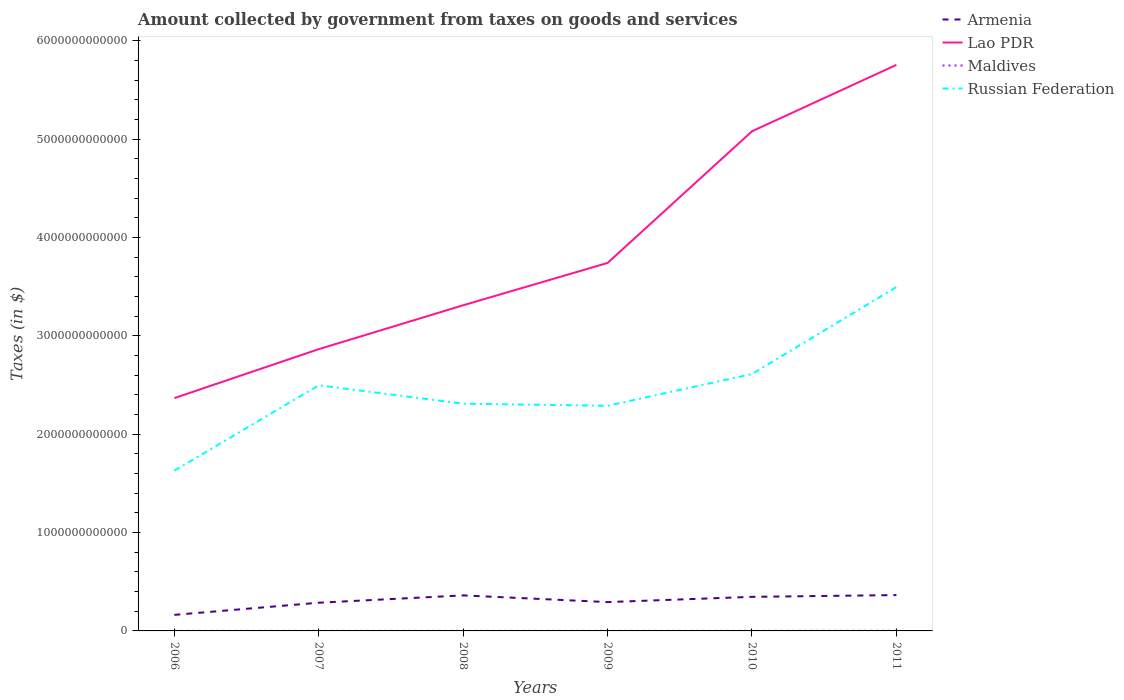How many different coloured lines are there?
Provide a succinct answer. 4. Does the line corresponding to Armenia intersect with the line corresponding to Russian Federation?
Keep it short and to the point. No. Is the number of lines equal to the number of legend labels?
Offer a terse response. Yes. Across all years, what is the maximum amount collected by government from taxes on goods and services in Russian Federation?
Your response must be concise. 1.63e+12. In which year was the amount collected by government from taxes on goods and services in Armenia maximum?
Provide a short and direct response. 2006. What is the total amount collected by government from taxes on goods and services in Lao PDR in the graph?
Offer a very short reply. -3.39e+12. What is the difference between the highest and the second highest amount collected by government from taxes on goods and services in Russian Federation?
Your answer should be very brief. 1.87e+12. What is the difference between the highest and the lowest amount collected by government from taxes on goods and services in Lao PDR?
Ensure brevity in your answer.  2. Is the amount collected by government from taxes on goods and services in Lao PDR strictly greater than the amount collected by government from taxes on goods and services in Armenia over the years?
Give a very brief answer. No. What is the difference between two consecutive major ticks on the Y-axis?
Your response must be concise. 1.00e+12. Are the values on the major ticks of Y-axis written in scientific E-notation?
Your answer should be very brief. No. Does the graph contain grids?
Offer a terse response. No. How many legend labels are there?
Make the answer very short. 4. What is the title of the graph?
Your answer should be very brief. Amount collected by government from taxes on goods and services. What is the label or title of the Y-axis?
Your answer should be compact. Taxes (in $). What is the Taxes (in $) in Armenia in 2006?
Provide a succinct answer. 1.63e+11. What is the Taxes (in $) in Lao PDR in 2006?
Offer a terse response. 2.37e+12. What is the Taxes (in $) in Maldives in 2006?
Your response must be concise. 5.49e+08. What is the Taxes (in $) in Russian Federation in 2006?
Offer a very short reply. 1.63e+12. What is the Taxes (in $) in Armenia in 2007?
Your response must be concise. 2.87e+11. What is the Taxes (in $) in Lao PDR in 2007?
Ensure brevity in your answer.  2.86e+12. What is the Taxes (in $) in Maldives in 2007?
Give a very brief answer. 6.08e+08. What is the Taxes (in $) of Russian Federation in 2007?
Your response must be concise. 2.50e+12. What is the Taxes (in $) of Armenia in 2008?
Provide a succinct answer. 3.61e+11. What is the Taxes (in $) of Lao PDR in 2008?
Give a very brief answer. 3.31e+12. What is the Taxes (in $) of Maldives in 2008?
Give a very brief answer. 6.38e+08. What is the Taxes (in $) of Russian Federation in 2008?
Keep it short and to the point. 2.31e+12. What is the Taxes (in $) of Armenia in 2009?
Provide a succinct answer. 2.93e+11. What is the Taxes (in $) of Lao PDR in 2009?
Provide a short and direct response. 3.74e+12. What is the Taxes (in $) in Maldives in 2009?
Ensure brevity in your answer.  6.10e+08. What is the Taxes (in $) in Russian Federation in 2009?
Your answer should be very brief. 2.29e+12. What is the Taxes (in $) of Armenia in 2010?
Offer a terse response. 3.46e+11. What is the Taxes (in $) in Lao PDR in 2010?
Keep it short and to the point. 5.08e+12. What is the Taxes (in $) in Maldives in 2010?
Keep it short and to the point. 6.35e+08. What is the Taxes (in $) of Russian Federation in 2010?
Your answer should be compact. 2.61e+12. What is the Taxes (in $) in Armenia in 2011?
Offer a very short reply. 3.64e+11. What is the Taxes (in $) in Lao PDR in 2011?
Keep it short and to the point. 5.75e+12. What is the Taxes (in $) of Maldives in 2011?
Provide a succinct answer. 1.66e+09. What is the Taxes (in $) in Russian Federation in 2011?
Your answer should be very brief. 3.50e+12. Across all years, what is the maximum Taxes (in $) of Armenia?
Ensure brevity in your answer.  3.64e+11. Across all years, what is the maximum Taxes (in $) in Lao PDR?
Keep it short and to the point. 5.75e+12. Across all years, what is the maximum Taxes (in $) in Maldives?
Offer a terse response. 1.66e+09. Across all years, what is the maximum Taxes (in $) in Russian Federation?
Your answer should be very brief. 3.50e+12. Across all years, what is the minimum Taxes (in $) of Armenia?
Ensure brevity in your answer.  1.63e+11. Across all years, what is the minimum Taxes (in $) of Lao PDR?
Provide a short and direct response. 2.37e+12. Across all years, what is the minimum Taxes (in $) in Maldives?
Ensure brevity in your answer.  5.49e+08. Across all years, what is the minimum Taxes (in $) of Russian Federation?
Your answer should be very brief. 1.63e+12. What is the total Taxes (in $) of Armenia in the graph?
Keep it short and to the point. 1.82e+12. What is the total Taxes (in $) of Lao PDR in the graph?
Give a very brief answer. 2.31e+13. What is the total Taxes (in $) of Maldives in the graph?
Your answer should be compact. 4.70e+09. What is the total Taxes (in $) of Russian Federation in the graph?
Ensure brevity in your answer.  1.48e+13. What is the difference between the Taxes (in $) of Armenia in 2006 and that in 2007?
Provide a succinct answer. -1.23e+11. What is the difference between the Taxes (in $) in Lao PDR in 2006 and that in 2007?
Make the answer very short. -4.98e+11. What is the difference between the Taxes (in $) of Maldives in 2006 and that in 2007?
Your answer should be very brief. -5.84e+07. What is the difference between the Taxes (in $) of Russian Federation in 2006 and that in 2007?
Your answer should be compact. -8.68e+11. What is the difference between the Taxes (in $) in Armenia in 2006 and that in 2008?
Make the answer very short. -1.98e+11. What is the difference between the Taxes (in $) in Lao PDR in 2006 and that in 2008?
Offer a terse response. -9.44e+11. What is the difference between the Taxes (in $) of Maldives in 2006 and that in 2008?
Offer a very short reply. -8.81e+07. What is the difference between the Taxes (in $) of Russian Federation in 2006 and that in 2008?
Your answer should be compact. -6.81e+11. What is the difference between the Taxes (in $) of Armenia in 2006 and that in 2009?
Keep it short and to the point. -1.30e+11. What is the difference between the Taxes (in $) of Lao PDR in 2006 and that in 2009?
Keep it short and to the point. -1.37e+12. What is the difference between the Taxes (in $) in Maldives in 2006 and that in 2009?
Your answer should be very brief. -6.10e+07. What is the difference between the Taxes (in $) in Russian Federation in 2006 and that in 2009?
Your answer should be compact. -6.60e+11. What is the difference between the Taxes (in $) of Armenia in 2006 and that in 2010?
Keep it short and to the point. -1.83e+11. What is the difference between the Taxes (in $) in Lao PDR in 2006 and that in 2010?
Your answer should be very brief. -2.71e+12. What is the difference between the Taxes (in $) in Maldives in 2006 and that in 2010?
Offer a very short reply. -8.57e+07. What is the difference between the Taxes (in $) of Russian Federation in 2006 and that in 2010?
Ensure brevity in your answer.  -9.83e+11. What is the difference between the Taxes (in $) in Armenia in 2006 and that in 2011?
Your response must be concise. -2.01e+11. What is the difference between the Taxes (in $) in Lao PDR in 2006 and that in 2011?
Provide a succinct answer. -3.39e+12. What is the difference between the Taxes (in $) of Maldives in 2006 and that in 2011?
Offer a terse response. -1.11e+09. What is the difference between the Taxes (in $) of Russian Federation in 2006 and that in 2011?
Give a very brief answer. -1.87e+12. What is the difference between the Taxes (in $) of Armenia in 2007 and that in 2008?
Keep it short and to the point. -7.45e+1. What is the difference between the Taxes (in $) of Lao PDR in 2007 and that in 2008?
Ensure brevity in your answer.  -4.46e+11. What is the difference between the Taxes (in $) in Maldives in 2007 and that in 2008?
Give a very brief answer. -2.97e+07. What is the difference between the Taxes (in $) in Russian Federation in 2007 and that in 2008?
Ensure brevity in your answer.  1.87e+11. What is the difference between the Taxes (in $) in Armenia in 2007 and that in 2009?
Your answer should be very brief. -6.40e+09. What is the difference between the Taxes (in $) of Lao PDR in 2007 and that in 2009?
Provide a short and direct response. -8.77e+11. What is the difference between the Taxes (in $) of Maldives in 2007 and that in 2009?
Give a very brief answer. -2.60e+06. What is the difference between the Taxes (in $) in Russian Federation in 2007 and that in 2009?
Keep it short and to the point. 2.08e+11. What is the difference between the Taxes (in $) in Armenia in 2007 and that in 2010?
Your response must be concise. -5.97e+1. What is the difference between the Taxes (in $) in Lao PDR in 2007 and that in 2010?
Your answer should be compact. -2.22e+12. What is the difference between the Taxes (in $) of Maldives in 2007 and that in 2010?
Your answer should be very brief. -2.73e+07. What is the difference between the Taxes (in $) of Russian Federation in 2007 and that in 2010?
Provide a short and direct response. -1.15e+11. What is the difference between the Taxes (in $) in Armenia in 2007 and that in 2011?
Offer a terse response. -7.77e+1. What is the difference between the Taxes (in $) in Lao PDR in 2007 and that in 2011?
Provide a short and direct response. -2.89e+12. What is the difference between the Taxes (in $) of Maldives in 2007 and that in 2011?
Keep it short and to the point. -1.05e+09. What is the difference between the Taxes (in $) of Russian Federation in 2007 and that in 2011?
Ensure brevity in your answer.  -9.99e+11. What is the difference between the Taxes (in $) in Armenia in 2008 and that in 2009?
Give a very brief answer. 6.81e+1. What is the difference between the Taxes (in $) of Lao PDR in 2008 and that in 2009?
Your answer should be very brief. -4.30e+11. What is the difference between the Taxes (in $) of Maldives in 2008 and that in 2009?
Offer a very short reply. 2.71e+07. What is the difference between the Taxes (in $) of Russian Federation in 2008 and that in 2009?
Make the answer very short. 2.16e+1. What is the difference between the Taxes (in $) in Armenia in 2008 and that in 2010?
Keep it short and to the point. 1.48e+1. What is the difference between the Taxes (in $) of Lao PDR in 2008 and that in 2010?
Make the answer very short. -1.77e+12. What is the difference between the Taxes (in $) in Maldives in 2008 and that in 2010?
Keep it short and to the point. 2.40e+06. What is the difference between the Taxes (in $) in Russian Federation in 2008 and that in 2010?
Keep it short and to the point. -3.01e+11. What is the difference between the Taxes (in $) in Armenia in 2008 and that in 2011?
Your response must be concise. -3.29e+09. What is the difference between the Taxes (in $) in Lao PDR in 2008 and that in 2011?
Make the answer very short. -2.44e+12. What is the difference between the Taxes (in $) of Maldives in 2008 and that in 2011?
Keep it short and to the point. -1.02e+09. What is the difference between the Taxes (in $) in Russian Federation in 2008 and that in 2011?
Give a very brief answer. -1.19e+12. What is the difference between the Taxes (in $) in Armenia in 2009 and that in 2010?
Keep it short and to the point. -5.33e+1. What is the difference between the Taxes (in $) in Lao PDR in 2009 and that in 2010?
Offer a very short reply. -1.34e+12. What is the difference between the Taxes (in $) in Maldives in 2009 and that in 2010?
Your response must be concise. -2.47e+07. What is the difference between the Taxes (in $) of Russian Federation in 2009 and that in 2010?
Offer a very short reply. -3.23e+11. What is the difference between the Taxes (in $) in Armenia in 2009 and that in 2011?
Make the answer very short. -7.13e+1. What is the difference between the Taxes (in $) in Lao PDR in 2009 and that in 2011?
Keep it short and to the point. -2.01e+12. What is the difference between the Taxes (in $) in Maldives in 2009 and that in 2011?
Your answer should be very brief. -1.05e+09. What is the difference between the Taxes (in $) in Russian Federation in 2009 and that in 2011?
Offer a terse response. -1.21e+12. What is the difference between the Taxes (in $) of Armenia in 2010 and that in 2011?
Your answer should be compact. -1.80e+1. What is the difference between the Taxes (in $) in Lao PDR in 2010 and that in 2011?
Give a very brief answer. -6.75e+11. What is the difference between the Taxes (in $) in Maldives in 2010 and that in 2011?
Give a very brief answer. -1.02e+09. What is the difference between the Taxes (in $) in Russian Federation in 2010 and that in 2011?
Ensure brevity in your answer.  -8.84e+11. What is the difference between the Taxes (in $) in Armenia in 2006 and the Taxes (in $) in Lao PDR in 2007?
Provide a succinct answer. -2.70e+12. What is the difference between the Taxes (in $) of Armenia in 2006 and the Taxes (in $) of Maldives in 2007?
Keep it short and to the point. 1.63e+11. What is the difference between the Taxes (in $) of Armenia in 2006 and the Taxes (in $) of Russian Federation in 2007?
Give a very brief answer. -2.33e+12. What is the difference between the Taxes (in $) of Lao PDR in 2006 and the Taxes (in $) of Maldives in 2007?
Keep it short and to the point. 2.37e+12. What is the difference between the Taxes (in $) in Lao PDR in 2006 and the Taxes (in $) in Russian Federation in 2007?
Your response must be concise. -1.30e+11. What is the difference between the Taxes (in $) in Maldives in 2006 and the Taxes (in $) in Russian Federation in 2007?
Ensure brevity in your answer.  -2.50e+12. What is the difference between the Taxes (in $) in Armenia in 2006 and the Taxes (in $) in Lao PDR in 2008?
Make the answer very short. -3.15e+12. What is the difference between the Taxes (in $) of Armenia in 2006 and the Taxes (in $) of Maldives in 2008?
Provide a short and direct response. 1.63e+11. What is the difference between the Taxes (in $) in Armenia in 2006 and the Taxes (in $) in Russian Federation in 2008?
Your response must be concise. -2.15e+12. What is the difference between the Taxes (in $) in Lao PDR in 2006 and the Taxes (in $) in Maldives in 2008?
Make the answer very short. 2.37e+12. What is the difference between the Taxes (in $) in Lao PDR in 2006 and the Taxes (in $) in Russian Federation in 2008?
Offer a very short reply. 5.63e+1. What is the difference between the Taxes (in $) in Maldives in 2006 and the Taxes (in $) in Russian Federation in 2008?
Provide a short and direct response. -2.31e+12. What is the difference between the Taxes (in $) of Armenia in 2006 and the Taxes (in $) of Lao PDR in 2009?
Offer a very short reply. -3.58e+12. What is the difference between the Taxes (in $) in Armenia in 2006 and the Taxes (in $) in Maldives in 2009?
Ensure brevity in your answer.  1.63e+11. What is the difference between the Taxes (in $) of Armenia in 2006 and the Taxes (in $) of Russian Federation in 2009?
Make the answer very short. -2.13e+12. What is the difference between the Taxes (in $) in Lao PDR in 2006 and the Taxes (in $) in Maldives in 2009?
Give a very brief answer. 2.37e+12. What is the difference between the Taxes (in $) of Lao PDR in 2006 and the Taxes (in $) of Russian Federation in 2009?
Your answer should be very brief. 7.79e+1. What is the difference between the Taxes (in $) of Maldives in 2006 and the Taxes (in $) of Russian Federation in 2009?
Provide a succinct answer. -2.29e+12. What is the difference between the Taxes (in $) in Armenia in 2006 and the Taxes (in $) in Lao PDR in 2010?
Your response must be concise. -4.92e+12. What is the difference between the Taxes (in $) in Armenia in 2006 and the Taxes (in $) in Maldives in 2010?
Give a very brief answer. 1.63e+11. What is the difference between the Taxes (in $) in Armenia in 2006 and the Taxes (in $) in Russian Federation in 2010?
Your response must be concise. -2.45e+12. What is the difference between the Taxes (in $) of Lao PDR in 2006 and the Taxes (in $) of Maldives in 2010?
Offer a very short reply. 2.37e+12. What is the difference between the Taxes (in $) in Lao PDR in 2006 and the Taxes (in $) in Russian Federation in 2010?
Your response must be concise. -2.45e+11. What is the difference between the Taxes (in $) of Maldives in 2006 and the Taxes (in $) of Russian Federation in 2010?
Ensure brevity in your answer.  -2.61e+12. What is the difference between the Taxes (in $) in Armenia in 2006 and the Taxes (in $) in Lao PDR in 2011?
Your answer should be compact. -5.59e+12. What is the difference between the Taxes (in $) of Armenia in 2006 and the Taxes (in $) of Maldives in 2011?
Offer a terse response. 1.62e+11. What is the difference between the Taxes (in $) in Armenia in 2006 and the Taxes (in $) in Russian Federation in 2011?
Provide a short and direct response. -3.33e+12. What is the difference between the Taxes (in $) in Lao PDR in 2006 and the Taxes (in $) in Maldives in 2011?
Provide a succinct answer. 2.37e+12. What is the difference between the Taxes (in $) of Lao PDR in 2006 and the Taxes (in $) of Russian Federation in 2011?
Offer a terse response. -1.13e+12. What is the difference between the Taxes (in $) of Maldives in 2006 and the Taxes (in $) of Russian Federation in 2011?
Your response must be concise. -3.50e+12. What is the difference between the Taxes (in $) of Armenia in 2007 and the Taxes (in $) of Lao PDR in 2008?
Ensure brevity in your answer.  -3.02e+12. What is the difference between the Taxes (in $) of Armenia in 2007 and the Taxes (in $) of Maldives in 2008?
Offer a very short reply. 2.86e+11. What is the difference between the Taxes (in $) of Armenia in 2007 and the Taxes (in $) of Russian Federation in 2008?
Ensure brevity in your answer.  -2.02e+12. What is the difference between the Taxes (in $) of Lao PDR in 2007 and the Taxes (in $) of Maldives in 2008?
Give a very brief answer. 2.86e+12. What is the difference between the Taxes (in $) in Lao PDR in 2007 and the Taxes (in $) in Russian Federation in 2008?
Provide a short and direct response. 5.54e+11. What is the difference between the Taxes (in $) of Maldives in 2007 and the Taxes (in $) of Russian Federation in 2008?
Provide a succinct answer. -2.31e+12. What is the difference between the Taxes (in $) of Armenia in 2007 and the Taxes (in $) of Lao PDR in 2009?
Keep it short and to the point. -3.45e+12. What is the difference between the Taxes (in $) of Armenia in 2007 and the Taxes (in $) of Maldives in 2009?
Offer a terse response. 2.86e+11. What is the difference between the Taxes (in $) in Armenia in 2007 and the Taxes (in $) in Russian Federation in 2009?
Your answer should be compact. -2.00e+12. What is the difference between the Taxes (in $) of Lao PDR in 2007 and the Taxes (in $) of Maldives in 2009?
Offer a very short reply. 2.86e+12. What is the difference between the Taxes (in $) of Lao PDR in 2007 and the Taxes (in $) of Russian Federation in 2009?
Provide a succinct answer. 5.76e+11. What is the difference between the Taxes (in $) of Maldives in 2007 and the Taxes (in $) of Russian Federation in 2009?
Provide a succinct answer. -2.29e+12. What is the difference between the Taxes (in $) of Armenia in 2007 and the Taxes (in $) of Lao PDR in 2010?
Your answer should be compact. -4.79e+12. What is the difference between the Taxes (in $) of Armenia in 2007 and the Taxes (in $) of Maldives in 2010?
Keep it short and to the point. 2.86e+11. What is the difference between the Taxes (in $) in Armenia in 2007 and the Taxes (in $) in Russian Federation in 2010?
Give a very brief answer. -2.33e+12. What is the difference between the Taxes (in $) in Lao PDR in 2007 and the Taxes (in $) in Maldives in 2010?
Your answer should be very brief. 2.86e+12. What is the difference between the Taxes (in $) of Lao PDR in 2007 and the Taxes (in $) of Russian Federation in 2010?
Ensure brevity in your answer.  2.53e+11. What is the difference between the Taxes (in $) in Maldives in 2007 and the Taxes (in $) in Russian Federation in 2010?
Your answer should be very brief. -2.61e+12. What is the difference between the Taxes (in $) in Armenia in 2007 and the Taxes (in $) in Lao PDR in 2011?
Your answer should be compact. -5.47e+12. What is the difference between the Taxes (in $) of Armenia in 2007 and the Taxes (in $) of Maldives in 2011?
Offer a very short reply. 2.85e+11. What is the difference between the Taxes (in $) of Armenia in 2007 and the Taxes (in $) of Russian Federation in 2011?
Your answer should be very brief. -3.21e+12. What is the difference between the Taxes (in $) in Lao PDR in 2007 and the Taxes (in $) in Maldives in 2011?
Offer a terse response. 2.86e+12. What is the difference between the Taxes (in $) in Lao PDR in 2007 and the Taxes (in $) in Russian Federation in 2011?
Your response must be concise. -6.32e+11. What is the difference between the Taxes (in $) of Maldives in 2007 and the Taxes (in $) of Russian Federation in 2011?
Your response must be concise. -3.50e+12. What is the difference between the Taxes (in $) in Armenia in 2008 and the Taxes (in $) in Lao PDR in 2009?
Keep it short and to the point. -3.38e+12. What is the difference between the Taxes (in $) in Armenia in 2008 and the Taxes (in $) in Maldives in 2009?
Keep it short and to the point. 3.61e+11. What is the difference between the Taxes (in $) in Armenia in 2008 and the Taxes (in $) in Russian Federation in 2009?
Provide a succinct answer. -1.93e+12. What is the difference between the Taxes (in $) of Lao PDR in 2008 and the Taxes (in $) of Maldives in 2009?
Make the answer very short. 3.31e+12. What is the difference between the Taxes (in $) of Lao PDR in 2008 and the Taxes (in $) of Russian Federation in 2009?
Keep it short and to the point. 1.02e+12. What is the difference between the Taxes (in $) of Maldives in 2008 and the Taxes (in $) of Russian Federation in 2009?
Offer a terse response. -2.29e+12. What is the difference between the Taxes (in $) of Armenia in 2008 and the Taxes (in $) of Lao PDR in 2010?
Ensure brevity in your answer.  -4.72e+12. What is the difference between the Taxes (in $) in Armenia in 2008 and the Taxes (in $) in Maldives in 2010?
Offer a terse response. 3.61e+11. What is the difference between the Taxes (in $) in Armenia in 2008 and the Taxes (in $) in Russian Federation in 2010?
Provide a succinct answer. -2.25e+12. What is the difference between the Taxes (in $) in Lao PDR in 2008 and the Taxes (in $) in Maldives in 2010?
Your answer should be compact. 3.31e+12. What is the difference between the Taxes (in $) in Lao PDR in 2008 and the Taxes (in $) in Russian Federation in 2010?
Your answer should be very brief. 6.99e+11. What is the difference between the Taxes (in $) in Maldives in 2008 and the Taxes (in $) in Russian Federation in 2010?
Give a very brief answer. -2.61e+12. What is the difference between the Taxes (in $) of Armenia in 2008 and the Taxes (in $) of Lao PDR in 2011?
Give a very brief answer. -5.39e+12. What is the difference between the Taxes (in $) in Armenia in 2008 and the Taxes (in $) in Maldives in 2011?
Keep it short and to the point. 3.60e+11. What is the difference between the Taxes (in $) in Armenia in 2008 and the Taxes (in $) in Russian Federation in 2011?
Make the answer very short. -3.14e+12. What is the difference between the Taxes (in $) of Lao PDR in 2008 and the Taxes (in $) of Maldives in 2011?
Provide a short and direct response. 3.31e+12. What is the difference between the Taxes (in $) in Lao PDR in 2008 and the Taxes (in $) in Russian Federation in 2011?
Your response must be concise. -1.86e+11. What is the difference between the Taxes (in $) of Maldives in 2008 and the Taxes (in $) of Russian Federation in 2011?
Give a very brief answer. -3.50e+12. What is the difference between the Taxes (in $) in Armenia in 2009 and the Taxes (in $) in Lao PDR in 2010?
Offer a very short reply. -4.79e+12. What is the difference between the Taxes (in $) in Armenia in 2009 and the Taxes (in $) in Maldives in 2010?
Offer a very short reply. 2.92e+11. What is the difference between the Taxes (in $) of Armenia in 2009 and the Taxes (in $) of Russian Federation in 2010?
Your answer should be very brief. -2.32e+12. What is the difference between the Taxes (in $) of Lao PDR in 2009 and the Taxes (in $) of Maldives in 2010?
Ensure brevity in your answer.  3.74e+12. What is the difference between the Taxes (in $) of Lao PDR in 2009 and the Taxes (in $) of Russian Federation in 2010?
Your answer should be very brief. 1.13e+12. What is the difference between the Taxes (in $) of Maldives in 2009 and the Taxes (in $) of Russian Federation in 2010?
Your answer should be compact. -2.61e+12. What is the difference between the Taxes (in $) in Armenia in 2009 and the Taxes (in $) in Lao PDR in 2011?
Provide a short and direct response. -5.46e+12. What is the difference between the Taxes (in $) of Armenia in 2009 and the Taxes (in $) of Maldives in 2011?
Offer a very short reply. 2.91e+11. What is the difference between the Taxes (in $) of Armenia in 2009 and the Taxes (in $) of Russian Federation in 2011?
Keep it short and to the point. -3.20e+12. What is the difference between the Taxes (in $) of Lao PDR in 2009 and the Taxes (in $) of Maldives in 2011?
Make the answer very short. 3.74e+12. What is the difference between the Taxes (in $) of Lao PDR in 2009 and the Taxes (in $) of Russian Federation in 2011?
Your answer should be very brief. 2.45e+11. What is the difference between the Taxes (in $) in Maldives in 2009 and the Taxes (in $) in Russian Federation in 2011?
Provide a short and direct response. -3.50e+12. What is the difference between the Taxes (in $) in Armenia in 2010 and the Taxes (in $) in Lao PDR in 2011?
Ensure brevity in your answer.  -5.41e+12. What is the difference between the Taxes (in $) in Armenia in 2010 and the Taxes (in $) in Maldives in 2011?
Your response must be concise. 3.45e+11. What is the difference between the Taxes (in $) in Armenia in 2010 and the Taxes (in $) in Russian Federation in 2011?
Provide a short and direct response. -3.15e+12. What is the difference between the Taxes (in $) of Lao PDR in 2010 and the Taxes (in $) of Maldives in 2011?
Offer a terse response. 5.08e+12. What is the difference between the Taxes (in $) of Lao PDR in 2010 and the Taxes (in $) of Russian Federation in 2011?
Your answer should be very brief. 1.58e+12. What is the difference between the Taxes (in $) of Maldives in 2010 and the Taxes (in $) of Russian Federation in 2011?
Make the answer very short. -3.50e+12. What is the average Taxes (in $) of Armenia per year?
Keep it short and to the point. 3.03e+11. What is the average Taxes (in $) in Lao PDR per year?
Your response must be concise. 3.85e+12. What is the average Taxes (in $) of Maldives per year?
Give a very brief answer. 7.83e+08. What is the average Taxes (in $) of Russian Federation per year?
Your answer should be very brief. 2.47e+12. In the year 2006, what is the difference between the Taxes (in $) of Armenia and Taxes (in $) of Lao PDR?
Offer a very short reply. -2.20e+12. In the year 2006, what is the difference between the Taxes (in $) in Armenia and Taxes (in $) in Maldives?
Offer a very short reply. 1.63e+11. In the year 2006, what is the difference between the Taxes (in $) in Armenia and Taxes (in $) in Russian Federation?
Offer a terse response. -1.47e+12. In the year 2006, what is the difference between the Taxes (in $) in Lao PDR and Taxes (in $) in Maldives?
Offer a very short reply. 2.37e+12. In the year 2006, what is the difference between the Taxes (in $) in Lao PDR and Taxes (in $) in Russian Federation?
Your response must be concise. 7.38e+11. In the year 2006, what is the difference between the Taxes (in $) of Maldives and Taxes (in $) of Russian Federation?
Provide a short and direct response. -1.63e+12. In the year 2007, what is the difference between the Taxes (in $) in Armenia and Taxes (in $) in Lao PDR?
Provide a succinct answer. -2.58e+12. In the year 2007, what is the difference between the Taxes (in $) in Armenia and Taxes (in $) in Maldives?
Your answer should be compact. 2.86e+11. In the year 2007, what is the difference between the Taxes (in $) in Armenia and Taxes (in $) in Russian Federation?
Give a very brief answer. -2.21e+12. In the year 2007, what is the difference between the Taxes (in $) of Lao PDR and Taxes (in $) of Maldives?
Offer a very short reply. 2.86e+12. In the year 2007, what is the difference between the Taxes (in $) of Lao PDR and Taxes (in $) of Russian Federation?
Offer a terse response. 3.67e+11. In the year 2007, what is the difference between the Taxes (in $) in Maldives and Taxes (in $) in Russian Federation?
Provide a succinct answer. -2.50e+12. In the year 2008, what is the difference between the Taxes (in $) of Armenia and Taxes (in $) of Lao PDR?
Provide a short and direct response. -2.95e+12. In the year 2008, what is the difference between the Taxes (in $) of Armenia and Taxes (in $) of Maldives?
Your answer should be very brief. 3.61e+11. In the year 2008, what is the difference between the Taxes (in $) of Armenia and Taxes (in $) of Russian Federation?
Provide a succinct answer. -1.95e+12. In the year 2008, what is the difference between the Taxes (in $) of Lao PDR and Taxes (in $) of Maldives?
Provide a succinct answer. 3.31e+12. In the year 2008, what is the difference between the Taxes (in $) in Lao PDR and Taxes (in $) in Russian Federation?
Provide a succinct answer. 1.00e+12. In the year 2008, what is the difference between the Taxes (in $) in Maldives and Taxes (in $) in Russian Federation?
Offer a terse response. -2.31e+12. In the year 2009, what is the difference between the Taxes (in $) in Armenia and Taxes (in $) in Lao PDR?
Offer a very short reply. -3.45e+12. In the year 2009, what is the difference between the Taxes (in $) of Armenia and Taxes (in $) of Maldives?
Give a very brief answer. 2.93e+11. In the year 2009, what is the difference between the Taxes (in $) in Armenia and Taxes (in $) in Russian Federation?
Your response must be concise. -2.00e+12. In the year 2009, what is the difference between the Taxes (in $) in Lao PDR and Taxes (in $) in Maldives?
Make the answer very short. 3.74e+12. In the year 2009, what is the difference between the Taxes (in $) of Lao PDR and Taxes (in $) of Russian Federation?
Ensure brevity in your answer.  1.45e+12. In the year 2009, what is the difference between the Taxes (in $) of Maldives and Taxes (in $) of Russian Federation?
Provide a short and direct response. -2.29e+12. In the year 2010, what is the difference between the Taxes (in $) of Armenia and Taxes (in $) of Lao PDR?
Give a very brief answer. -4.73e+12. In the year 2010, what is the difference between the Taxes (in $) in Armenia and Taxes (in $) in Maldives?
Provide a short and direct response. 3.46e+11. In the year 2010, what is the difference between the Taxes (in $) in Armenia and Taxes (in $) in Russian Federation?
Offer a terse response. -2.27e+12. In the year 2010, what is the difference between the Taxes (in $) of Lao PDR and Taxes (in $) of Maldives?
Make the answer very short. 5.08e+12. In the year 2010, what is the difference between the Taxes (in $) of Lao PDR and Taxes (in $) of Russian Federation?
Make the answer very short. 2.47e+12. In the year 2010, what is the difference between the Taxes (in $) of Maldives and Taxes (in $) of Russian Federation?
Your answer should be very brief. -2.61e+12. In the year 2011, what is the difference between the Taxes (in $) in Armenia and Taxes (in $) in Lao PDR?
Provide a short and direct response. -5.39e+12. In the year 2011, what is the difference between the Taxes (in $) of Armenia and Taxes (in $) of Maldives?
Offer a very short reply. 3.63e+11. In the year 2011, what is the difference between the Taxes (in $) in Armenia and Taxes (in $) in Russian Federation?
Make the answer very short. -3.13e+12. In the year 2011, what is the difference between the Taxes (in $) in Lao PDR and Taxes (in $) in Maldives?
Your answer should be very brief. 5.75e+12. In the year 2011, what is the difference between the Taxes (in $) of Lao PDR and Taxes (in $) of Russian Federation?
Provide a short and direct response. 2.26e+12. In the year 2011, what is the difference between the Taxes (in $) of Maldives and Taxes (in $) of Russian Federation?
Your response must be concise. -3.49e+12. What is the ratio of the Taxes (in $) of Armenia in 2006 to that in 2007?
Offer a very short reply. 0.57. What is the ratio of the Taxes (in $) of Lao PDR in 2006 to that in 2007?
Offer a very short reply. 0.83. What is the ratio of the Taxes (in $) in Maldives in 2006 to that in 2007?
Your answer should be very brief. 0.9. What is the ratio of the Taxes (in $) in Russian Federation in 2006 to that in 2007?
Provide a succinct answer. 0.65. What is the ratio of the Taxes (in $) in Armenia in 2006 to that in 2008?
Offer a terse response. 0.45. What is the ratio of the Taxes (in $) of Lao PDR in 2006 to that in 2008?
Your answer should be compact. 0.71. What is the ratio of the Taxes (in $) in Maldives in 2006 to that in 2008?
Give a very brief answer. 0.86. What is the ratio of the Taxes (in $) of Russian Federation in 2006 to that in 2008?
Make the answer very short. 0.71. What is the ratio of the Taxes (in $) in Armenia in 2006 to that in 2009?
Your answer should be very brief. 0.56. What is the ratio of the Taxes (in $) in Lao PDR in 2006 to that in 2009?
Offer a terse response. 0.63. What is the ratio of the Taxes (in $) of Maldives in 2006 to that in 2009?
Give a very brief answer. 0.9. What is the ratio of the Taxes (in $) of Russian Federation in 2006 to that in 2009?
Ensure brevity in your answer.  0.71. What is the ratio of the Taxes (in $) in Armenia in 2006 to that in 2010?
Provide a succinct answer. 0.47. What is the ratio of the Taxes (in $) of Lao PDR in 2006 to that in 2010?
Your response must be concise. 0.47. What is the ratio of the Taxes (in $) in Maldives in 2006 to that in 2010?
Provide a succinct answer. 0.87. What is the ratio of the Taxes (in $) of Russian Federation in 2006 to that in 2010?
Make the answer very short. 0.62. What is the ratio of the Taxes (in $) in Armenia in 2006 to that in 2011?
Your response must be concise. 0.45. What is the ratio of the Taxes (in $) in Lao PDR in 2006 to that in 2011?
Offer a terse response. 0.41. What is the ratio of the Taxes (in $) in Maldives in 2006 to that in 2011?
Provide a short and direct response. 0.33. What is the ratio of the Taxes (in $) of Russian Federation in 2006 to that in 2011?
Ensure brevity in your answer.  0.47. What is the ratio of the Taxes (in $) of Armenia in 2007 to that in 2008?
Your answer should be very brief. 0.79. What is the ratio of the Taxes (in $) of Lao PDR in 2007 to that in 2008?
Your answer should be compact. 0.87. What is the ratio of the Taxes (in $) in Maldives in 2007 to that in 2008?
Ensure brevity in your answer.  0.95. What is the ratio of the Taxes (in $) in Russian Federation in 2007 to that in 2008?
Your answer should be very brief. 1.08. What is the ratio of the Taxes (in $) of Armenia in 2007 to that in 2009?
Offer a terse response. 0.98. What is the ratio of the Taxes (in $) in Lao PDR in 2007 to that in 2009?
Give a very brief answer. 0.77. What is the ratio of the Taxes (in $) of Maldives in 2007 to that in 2009?
Make the answer very short. 1. What is the ratio of the Taxes (in $) of Russian Federation in 2007 to that in 2009?
Provide a succinct answer. 1.09. What is the ratio of the Taxes (in $) in Armenia in 2007 to that in 2010?
Provide a short and direct response. 0.83. What is the ratio of the Taxes (in $) of Lao PDR in 2007 to that in 2010?
Your answer should be compact. 0.56. What is the ratio of the Taxes (in $) in Maldives in 2007 to that in 2010?
Keep it short and to the point. 0.96. What is the ratio of the Taxes (in $) of Russian Federation in 2007 to that in 2010?
Ensure brevity in your answer.  0.96. What is the ratio of the Taxes (in $) of Armenia in 2007 to that in 2011?
Your response must be concise. 0.79. What is the ratio of the Taxes (in $) in Lao PDR in 2007 to that in 2011?
Give a very brief answer. 0.5. What is the ratio of the Taxes (in $) in Maldives in 2007 to that in 2011?
Provide a succinct answer. 0.37. What is the ratio of the Taxes (in $) in Russian Federation in 2007 to that in 2011?
Keep it short and to the point. 0.71. What is the ratio of the Taxes (in $) of Armenia in 2008 to that in 2009?
Make the answer very short. 1.23. What is the ratio of the Taxes (in $) of Lao PDR in 2008 to that in 2009?
Ensure brevity in your answer.  0.89. What is the ratio of the Taxes (in $) in Maldives in 2008 to that in 2009?
Offer a terse response. 1.04. What is the ratio of the Taxes (in $) of Russian Federation in 2008 to that in 2009?
Offer a very short reply. 1.01. What is the ratio of the Taxes (in $) of Armenia in 2008 to that in 2010?
Make the answer very short. 1.04. What is the ratio of the Taxes (in $) in Lao PDR in 2008 to that in 2010?
Keep it short and to the point. 0.65. What is the ratio of the Taxes (in $) in Maldives in 2008 to that in 2010?
Make the answer very short. 1. What is the ratio of the Taxes (in $) of Russian Federation in 2008 to that in 2010?
Offer a terse response. 0.88. What is the ratio of the Taxes (in $) of Lao PDR in 2008 to that in 2011?
Offer a terse response. 0.58. What is the ratio of the Taxes (in $) in Maldives in 2008 to that in 2011?
Offer a terse response. 0.38. What is the ratio of the Taxes (in $) of Russian Federation in 2008 to that in 2011?
Keep it short and to the point. 0.66. What is the ratio of the Taxes (in $) in Armenia in 2009 to that in 2010?
Your answer should be compact. 0.85. What is the ratio of the Taxes (in $) of Lao PDR in 2009 to that in 2010?
Ensure brevity in your answer.  0.74. What is the ratio of the Taxes (in $) in Maldives in 2009 to that in 2010?
Your answer should be compact. 0.96. What is the ratio of the Taxes (in $) in Russian Federation in 2009 to that in 2010?
Give a very brief answer. 0.88. What is the ratio of the Taxes (in $) in Armenia in 2009 to that in 2011?
Your answer should be very brief. 0.8. What is the ratio of the Taxes (in $) in Lao PDR in 2009 to that in 2011?
Offer a terse response. 0.65. What is the ratio of the Taxes (in $) in Maldives in 2009 to that in 2011?
Offer a terse response. 0.37. What is the ratio of the Taxes (in $) of Russian Federation in 2009 to that in 2011?
Offer a terse response. 0.65. What is the ratio of the Taxes (in $) in Armenia in 2010 to that in 2011?
Give a very brief answer. 0.95. What is the ratio of the Taxes (in $) in Lao PDR in 2010 to that in 2011?
Your answer should be very brief. 0.88. What is the ratio of the Taxes (in $) of Maldives in 2010 to that in 2011?
Provide a short and direct response. 0.38. What is the ratio of the Taxes (in $) of Russian Federation in 2010 to that in 2011?
Give a very brief answer. 0.75. What is the difference between the highest and the second highest Taxes (in $) of Armenia?
Make the answer very short. 3.29e+09. What is the difference between the highest and the second highest Taxes (in $) of Lao PDR?
Offer a very short reply. 6.75e+11. What is the difference between the highest and the second highest Taxes (in $) of Maldives?
Keep it short and to the point. 1.02e+09. What is the difference between the highest and the second highest Taxes (in $) of Russian Federation?
Ensure brevity in your answer.  8.84e+11. What is the difference between the highest and the lowest Taxes (in $) of Armenia?
Your answer should be compact. 2.01e+11. What is the difference between the highest and the lowest Taxes (in $) of Lao PDR?
Ensure brevity in your answer.  3.39e+12. What is the difference between the highest and the lowest Taxes (in $) of Maldives?
Offer a terse response. 1.11e+09. What is the difference between the highest and the lowest Taxes (in $) in Russian Federation?
Offer a very short reply. 1.87e+12. 